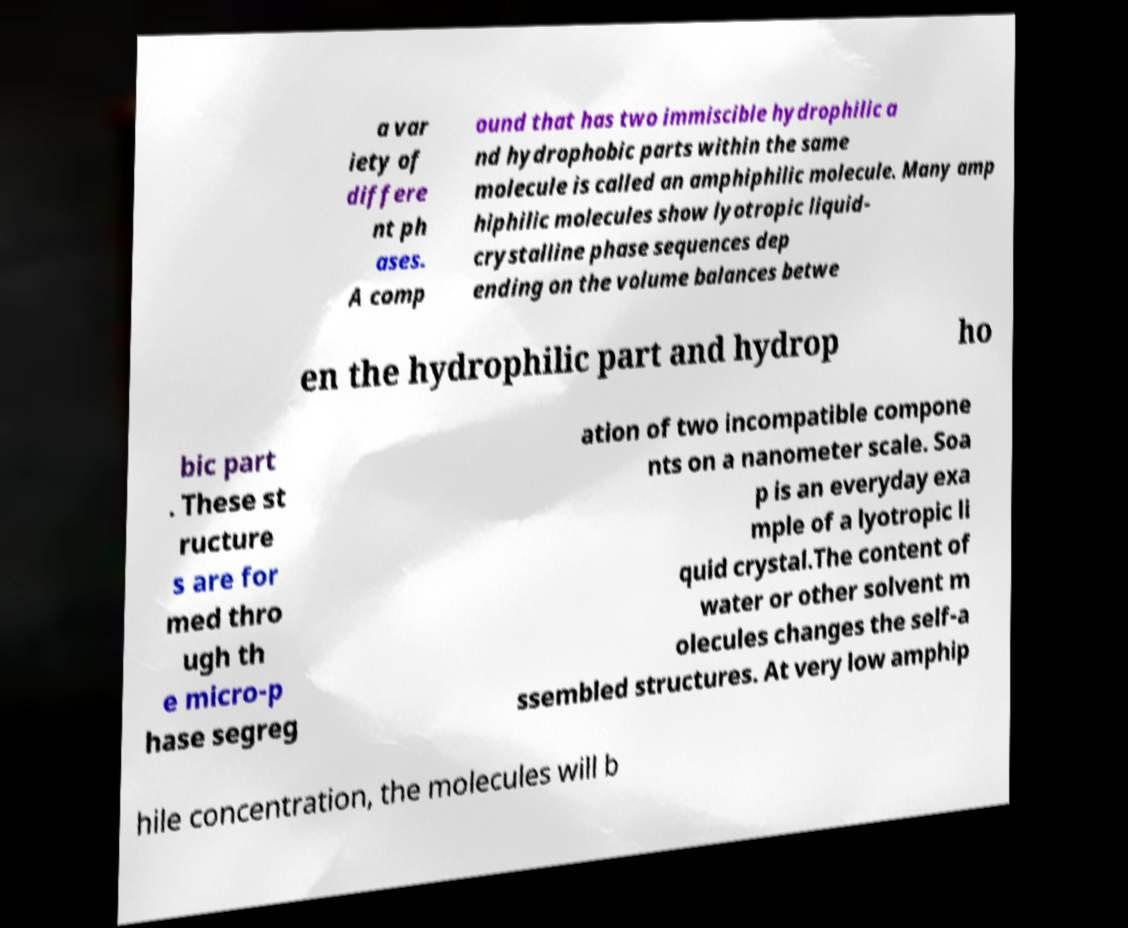Can you read and provide the text displayed in the image?This photo seems to have some interesting text. Can you extract and type it out for me? a var iety of differe nt ph ases. A comp ound that has two immiscible hydrophilic a nd hydrophobic parts within the same molecule is called an amphiphilic molecule. Many amp hiphilic molecules show lyotropic liquid- crystalline phase sequences dep ending on the volume balances betwe en the hydrophilic part and hydrop ho bic part . These st ructure s are for med thro ugh th e micro-p hase segreg ation of two incompatible compone nts on a nanometer scale. Soa p is an everyday exa mple of a lyotropic li quid crystal.The content of water or other solvent m olecules changes the self-a ssembled structures. At very low amphip hile concentration, the molecules will b 